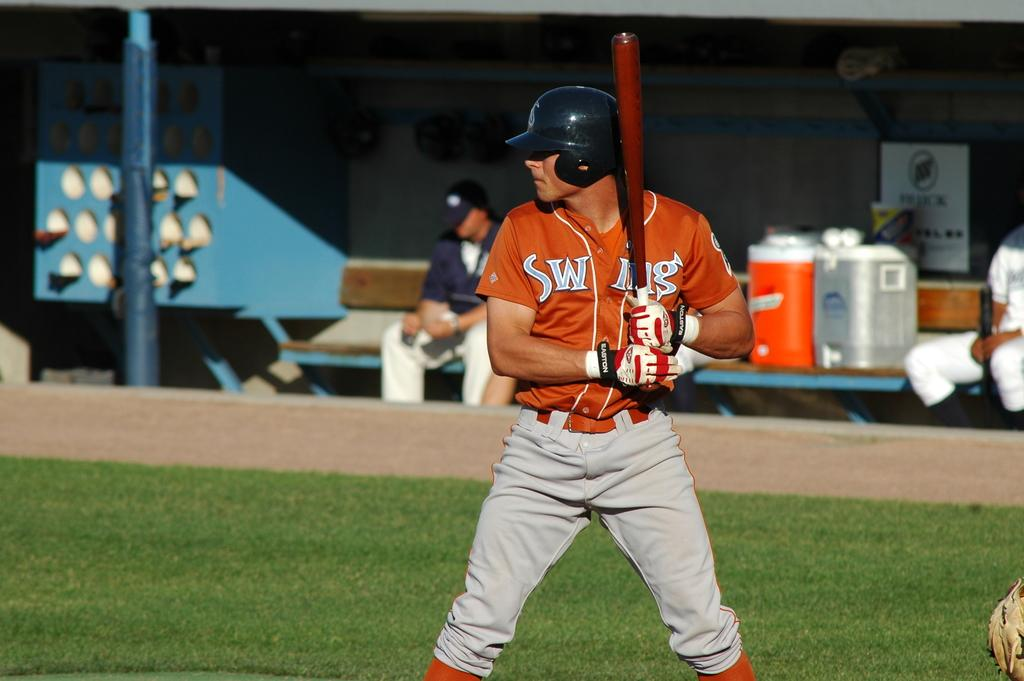Provide a one-sentence caption for the provided image. A baseball batter's shirt, which appears to say "Swing", is partly covered by his bat. 